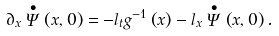Convert formula to latex. <formula><loc_0><loc_0><loc_500><loc_500>\partial _ { x } \stackrel { \bullet } { \Psi } \left ( x , 0 \right ) = - l _ { t } g ^ { - 1 } \left ( x \right ) - l _ { x } \stackrel { \bullet } { \Psi } \left ( x , 0 \right ) .</formula> 